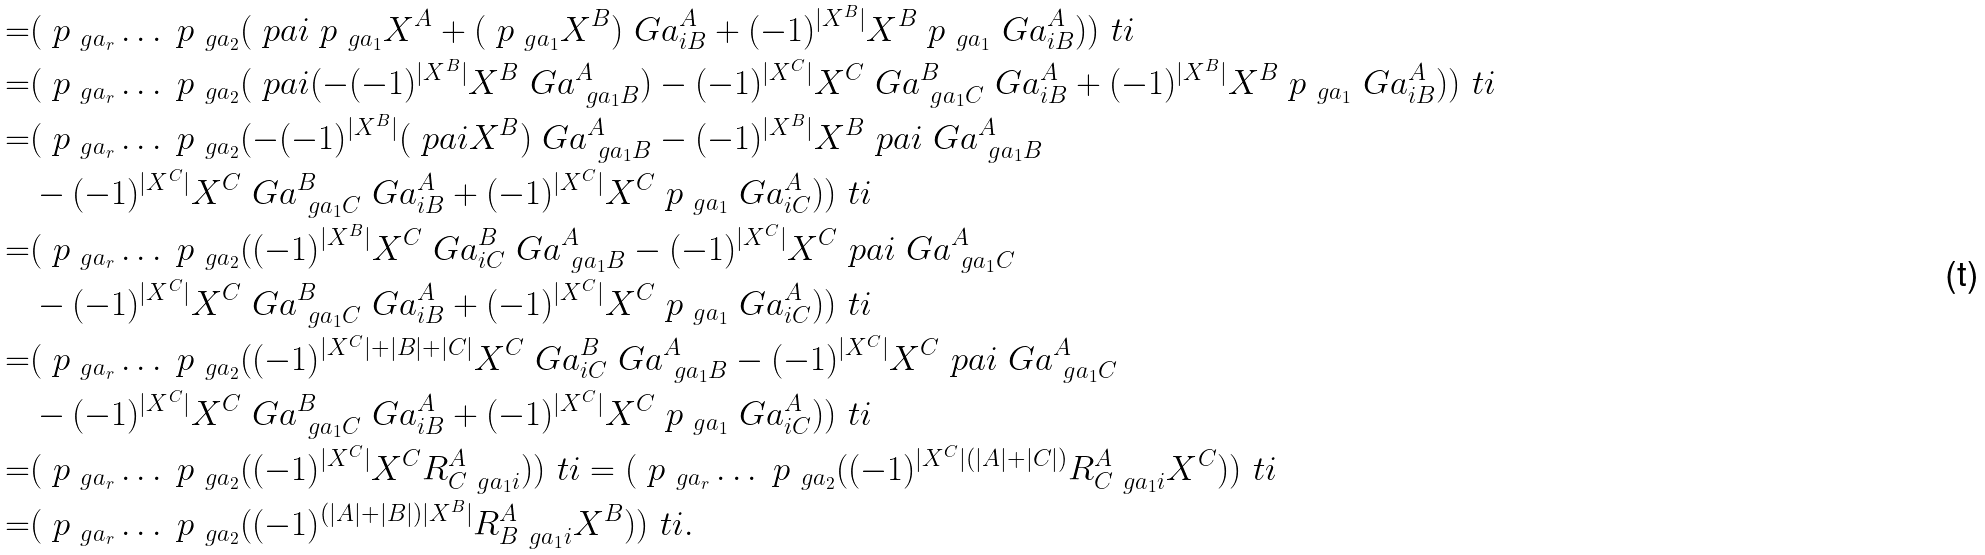<formula> <loc_0><loc_0><loc_500><loc_500>= & ( \ p _ { \ g a _ { r } } \dots \ p _ { \ g a _ { 2 } } ( \ p a i \ p _ { \ g a _ { 1 } } X ^ { A } + ( \ p _ { \ g a _ { 1 } } X ^ { B } ) \ G a ^ { A } _ { i B } + ( - 1 ) ^ { | X ^ { B } | } X ^ { B } \ p _ { \ g a _ { 1 } } \ G a ^ { A } _ { i B } ) ) ^ { \ } t i \\ = & ( \ p _ { \ g a _ { r } } \dots \ p _ { \ g a _ { 2 } } ( \ p a i ( - ( - 1 ) ^ { | X ^ { B } | } X ^ { B } \ G a ^ { A } _ { \ g a _ { 1 } B } ) - ( - 1 ) ^ { | X ^ { C } | } X ^ { C } \ G a ^ { B } _ { \ g a _ { 1 } C } \ G a ^ { A } _ { i B } + ( - 1 ) ^ { | X ^ { B } | } X ^ { B } \ p _ { \ g a _ { 1 } } \ G a ^ { A } _ { i B } ) ) ^ { \ } t i \\ = & ( \ p _ { \ g a _ { r } } \dots \ p _ { \ g a _ { 2 } } ( - ( - 1 ) ^ { | X ^ { B } | } ( \ p a i X ^ { B } ) \ G a ^ { A } _ { \ g a _ { 1 } B } - ( - 1 ) ^ { | X ^ { B } | } X ^ { B } \ p a i \ G a ^ { A } _ { \ g a _ { 1 } B } \\ & - ( - 1 ) ^ { | X ^ { C } | } X ^ { C } \ G a ^ { B } _ { \ g a _ { 1 } C } \ G a ^ { A } _ { i B } + ( - 1 ) ^ { | X ^ { C } | } X ^ { C } \ p _ { \ g a _ { 1 } } \ G a ^ { A } _ { i C } ) ) ^ { \ } t i \\ = & ( \ p _ { \ g a _ { r } } \dots \ p _ { \ g a _ { 2 } } ( ( - 1 ) ^ { | X ^ { B } | } X ^ { C } \ G a ^ { B } _ { i C } \ G a ^ { A } _ { \ g a _ { 1 } B } - ( - 1 ) ^ { | X ^ { C } | } X ^ { C } \ p a i \ G a ^ { A } _ { \ g a _ { 1 } C } \\ & - ( - 1 ) ^ { | X ^ { C } | } X ^ { C } \ G a ^ { B } _ { \ g a _ { 1 } C } \ G a ^ { A } _ { i B } + ( - 1 ) ^ { | X ^ { C } | } X ^ { C } \ p _ { \ g a _ { 1 } } \ G a ^ { A } _ { i C } ) ) ^ { \ } t i \\ = & ( \ p _ { \ g a _ { r } } \dots \ p _ { \ g a _ { 2 } } ( ( - 1 ) ^ { | X ^ { C } | + | B | + | C | } X ^ { C } \ G a ^ { B } _ { i C } \ G a ^ { A } _ { \ g a _ { 1 } B } - ( - 1 ) ^ { | X ^ { C } | } X ^ { C } \ p a i \ G a ^ { A } _ { \ g a _ { 1 } C } \\ & - ( - 1 ) ^ { | X ^ { C } | } X ^ { C } \ G a ^ { B } _ { \ g a _ { 1 } C } \ G a ^ { A } _ { i B } + ( - 1 ) ^ { | X ^ { C } | } X ^ { C } \ p _ { \ g a _ { 1 } } \ G a ^ { A } _ { i C } ) ) ^ { \ } t i \\ = & ( \ p _ { \ g a _ { r } } \dots \ p _ { \ g a _ { 2 } } ( ( - 1 ) ^ { | X ^ { C } | } X ^ { C } R ^ { A } _ { C \ g a _ { 1 } i } ) ) ^ { \ } t i = ( \ p _ { \ g a _ { r } } \dots \ p _ { \ g a _ { 2 } } ( ( - 1 ) ^ { | X ^ { C } | ( | A | + | C | ) } R ^ { A } _ { C \ g a _ { 1 } i } X ^ { C } ) ) ^ { \ } t i \\ = & ( \ p _ { \ g a _ { r } } \dots \ p _ { \ g a _ { 2 } } ( ( - 1 ) ^ { ( | A | + | B | ) | X ^ { B } | } R ^ { A } _ { B \ g a _ { 1 } i } X ^ { B } ) ) ^ { \ } t i .</formula> 